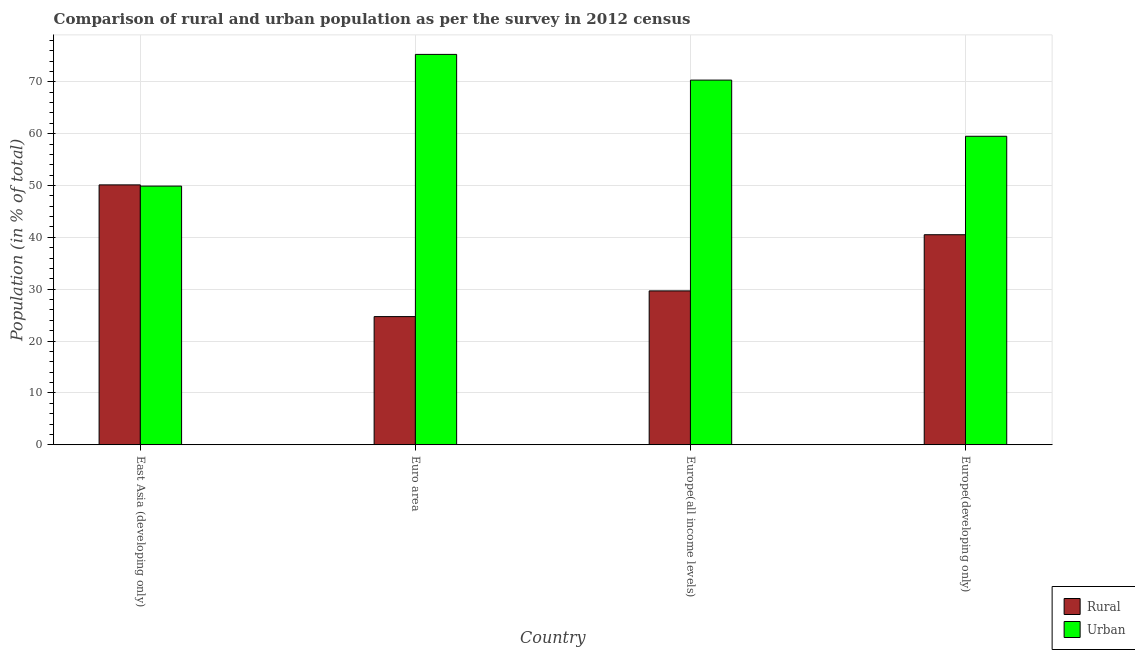How many groups of bars are there?
Your answer should be compact. 4. Are the number of bars per tick equal to the number of legend labels?
Provide a short and direct response. Yes. Are the number of bars on each tick of the X-axis equal?
Give a very brief answer. Yes. How many bars are there on the 2nd tick from the right?
Keep it short and to the point. 2. In how many cases, is the number of bars for a given country not equal to the number of legend labels?
Ensure brevity in your answer.  0. What is the urban population in Europe(all income levels)?
Provide a succinct answer. 70.32. Across all countries, what is the maximum urban population?
Offer a terse response. 75.28. Across all countries, what is the minimum urban population?
Provide a succinct answer. 49.88. In which country was the rural population maximum?
Your answer should be compact. East Asia (developing only). In which country was the urban population minimum?
Ensure brevity in your answer.  East Asia (developing only). What is the total urban population in the graph?
Offer a very short reply. 254.98. What is the difference between the urban population in Euro area and that in Europe(developing only)?
Offer a very short reply. 15.79. What is the difference between the urban population in Europe(all income levels) and the rural population in Europe(developing only)?
Ensure brevity in your answer.  29.82. What is the average rural population per country?
Give a very brief answer. 36.26. What is the difference between the urban population and rural population in Europe(developing only)?
Make the answer very short. 18.98. In how many countries, is the urban population greater than 12 %?
Provide a succinct answer. 4. What is the ratio of the rural population in East Asia (developing only) to that in Europe(all income levels)?
Ensure brevity in your answer.  1.69. What is the difference between the highest and the second highest rural population?
Offer a very short reply. 9.61. What is the difference between the highest and the lowest rural population?
Provide a succinct answer. 25.4. Is the sum of the urban population in Europe(all income levels) and Europe(developing only) greater than the maximum rural population across all countries?
Your answer should be very brief. Yes. What does the 2nd bar from the left in Euro area represents?
Offer a very short reply. Urban. What does the 2nd bar from the right in Euro area represents?
Give a very brief answer. Rural. How many bars are there?
Offer a very short reply. 8. Are all the bars in the graph horizontal?
Your answer should be compact. No. What is the difference between two consecutive major ticks on the Y-axis?
Your response must be concise. 10. Are the values on the major ticks of Y-axis written in scientific E-notation?
Your answer should be compact. No. How many legend labels are there?
Provide a short and direct response. 2. How are the legend labels stacked?
Provide a short and direct response. Vertical. What is the title of the graph?
Your response must be concise. Comparison of rural and urban population as per the survey in 2012 census. What is the label or title of the Y-axis?
Keep it short and to the point. Population (in % of total). What is the Population (in % of total) of Rural in East Asia (developing only)?
Your response must be concise. 50.12. What is the Population (in % of total) of Urban in East Asia (developing only)?
Your answer should be very brief. 49.88. What is the Population (in % of total) of Rural in Euro area?
Make the answer very short. 24.72. What is the Population (in % of total) of Urban in Euro area?
Your answer should be very brief. 75.28. What is the Population (in % of total) of Rural in Europe(all income levels)?
Offer a very short reply. 29.68. What is the Population (in % of total) of Urban in Europe(all income levels)?
Offer a terse response. 70.32. What is the Population (in % of total) in Rural in Europe(developing only)?
Make the answer very short. 40.51. What is the Population (in % of total) of Urban in Europe(developing only)?
Offer a very short reply. 59.49. Across all countries, what is the maximum Population (in % of total) in Rural?
Offer a terse response. 50.12. Across all countries, what is the maximum Population (in % of total) of Urban?
Give a very brief answer. 75.28. Across all countries, what is the minimum Population (in % of total) in Rural?
Offer a terse response. 24.72. Across all countries, what is the minimum Population (in % of total) of Urban?
Your answer should be very brief. 49.88. What is the total Population (in % of total) of Rural in the graph?
Provide a short and direct response. 145.02. What is the total Population (in % of total) of Urban in the graph?
Ensure brevity in your answer.  254.98. What is the difference between the Population (in % of total) of Rural in East Asia (developing only) and that in Euro area?
Your response must be concise. 25.4. What is the difference between the Population (in % of total) in Urban in East Asia (developing only) and that in Euro area?
Provide a succinct answer. -25.4. What is the difference between the Population (in % of total) of Rural in East Asia (developing only) and that in Europe(all income levels)?
Give a very brief answer. 20.44. What is the difference between the Population (in % of total) in Urban in East Asia (developing only) and that in Europe(all income levels)?
Give a very brief answer. -20.44. What is the difference between the Population (in % of total) in Rural in East Asia (developing only) and that in Europe(developing only)?
Provide a short and direct response. 9.61. What is the difference between the Population (in % of total) of Urban in East Asia (developing only) and that in Europe(developing only)?
Keep it short and to the point. -9.61. What is the difference between the Population (in % of total) in Rural in Euro area and that in Europe(all income levels)?
Offer a terse response. -4.96. What is the difference between the Population (in % of total) of Urban in Euro area and that in Europe(all income levels)?
Give a very brief answer. 4.96. What is the difference between the Population (in % of total) in Rural in Euro area and that in Europe(developing only)?
Offer a terse response. -15.79. What is the difference between the Population (in % of total) of Urban in Euro area and that in Europe(developing only)?
Offer a very short reply. 15.79. What is the difference between the Population (in % of total) of Rural in Europe(all income levels) and that in Europe(developing only)?
Make the answer very short. -10.83. What is the difference between the Population (in % of total) of Urban in Europe(all income levels) and that in Europe(developing only)?
Offer a very short reply. 10.83. What is the difference between the Population (in % of total) in Rural in East Asia (developing only) and the Population (in % of total) in Urban in Euro area?
Keep it short and to the point. -25.16. What is the difference between the Population (in % of total) of Rural in East Asia (developing only) and the Population (in % of total) of Urban in Europe(all income levels)?
Make the answer very short. -20.21. What is the difference between the Population (in % of total) in Rural in East Asia (developing only) and the Population (in % of total) in Urban in Europe(developing only)?
Offer a terse response. -9.37. What is the difference between the Population (in % of total) in Rural in Euro area and the Population (in % of total) in Urban in Europe(all income levels)?
Keep it short and to the point. -45.6. What is the difference between the Population (in % of total) of Rural in Euro area and the Population (in % of total) of Urban in Europe(developing only)?
Offer a very short reply. -34.77. What is the difference between the Population (in % of total) in Rural in Europe(all income levels) and the Population (in % of total) in Urban in Europe(developing only)?
Your response must be concise. -29.82. What is the average Population (in % of total) in Rural per country?
Your response must be concise. 36.26. What is the average Population (in % of total) of Urban per country?
Provide a short and direct response. 63.74. What is the difference between the Population (in % of total) of Rural and Population (in % of total) of Urban in East Asia (developing only)?
Offer a terse response. 0.24. What is the difference between the Population (in % of total) in Rural and Population (in % of total) in Urban in Euro area?
Provide a short and direct response. -50.56. What is the difference between the Population (in % of total) of Rural and Population (in % of total) of Urban in Europe(all income levels)?
Provide a short and direct response. -40.65. What is the difference between the Population (in % of total) in Rural and Population (in % of total) in Urban in Europe(developing only)?
Offer a terse response. -18.98. What is the ratio of the Population (in % of total) in Rural in East Asia (developing only) to that in Euro area?
Provide a succinct answer. 2.03. What is the ratio of the Population (in % of total) in Urban in East Asia (developing only) to that in Euro area?
Offer a terse response. 0.66. What is the ratio of the Population (in % of total) of Rural in East Asia (developing only) to that in Europe(all income levels)?
Ensure brevity in your answer.  1.69. What is the ratio of the Population (in % of total) in Urban in East Asia (developing only) to that in Europe(all income levels)?
Make the answer very short. 0.71. What is the ratio of the Population (in % of total) of Rural in East Asia (developing only) to that in Europe(developing only)?
Keep it short and to the point. 1.24. What is the ratio of the Population (in % of total) in Urban in East Asia (developing only) to that in Europe(developing only)?
Keep it short and to the point. 0.84. What is the ratio of the Population (in % of total) in Rural in Euro area to that in Europe(all income levels)?
Provide a succinct answer. 0.83. What is the ratio of the Population (in % of total) in Urban in Euro area to that in Europe(all income levels)?
Your answer should be very brief. 1.07. What is the ratio of the Population (in % of total) of Rural in Euro area to that in Europe(developing only)?
Your answer should be very brief. 0.61. What is the ratio of the Population (in % of total) in Urban in Euro area to that in Europe(developing only)?
Keep it short and to the point. 1.27. What is the ratio of the Population (in % of total) in Rural in Europe(all income levels) to that in Europe(developing only)?
Make the answer very short. 0.73. What is the ratio of the Population (in % of total) of Urban in Europe(all income levels) to that in Europe(developing only)?
Provide a succinct answer. 1.18. What is the difference between the highest and the second highest Population (in % of total) in Rural?
Ensure brevity in your answer.  9.61. What is the difference between the highest and the second highest Population (in % of total) of Urban?
Offer a terse response. 4.96. What is the difference between the highest and the lowest Population (in % of total) in Rural?
Offer a terse response. 25.4. What is the difference between the highest and the lowest Population (in % of total) of Urban?
Provide a short and direct response. 25.4. 